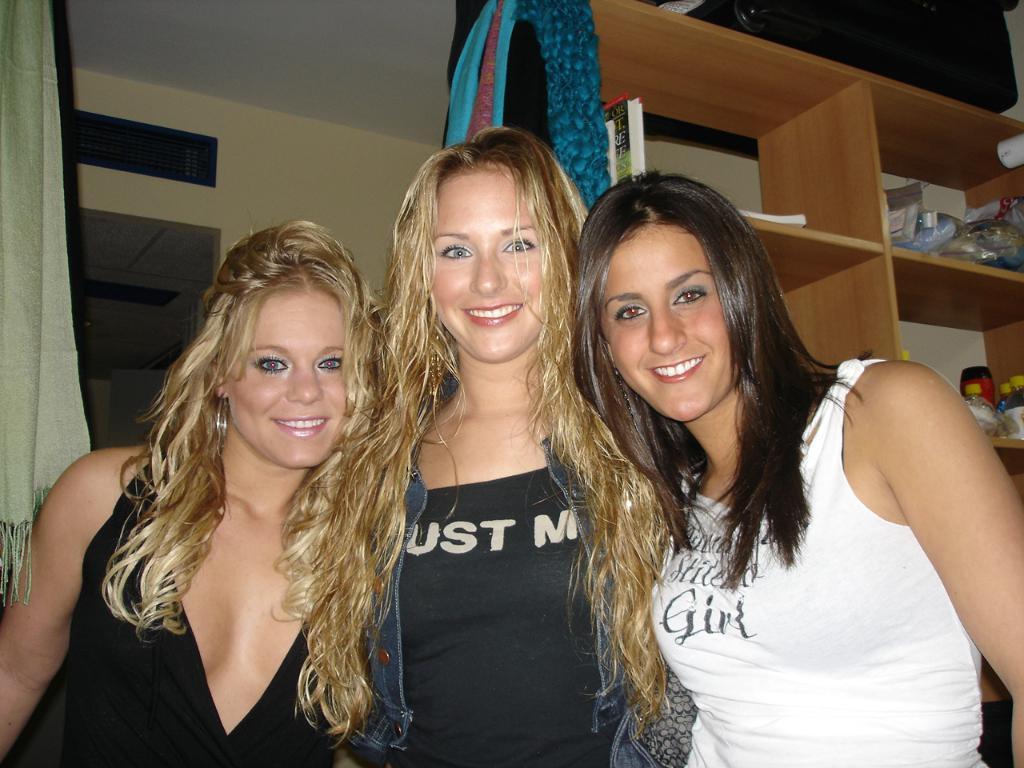Please provide a concise description of this image. In this picture we can see three women, they are all smiling, behind to them we can see few covers, bottles, books and other things in the racks, and also we can see few clothes. 